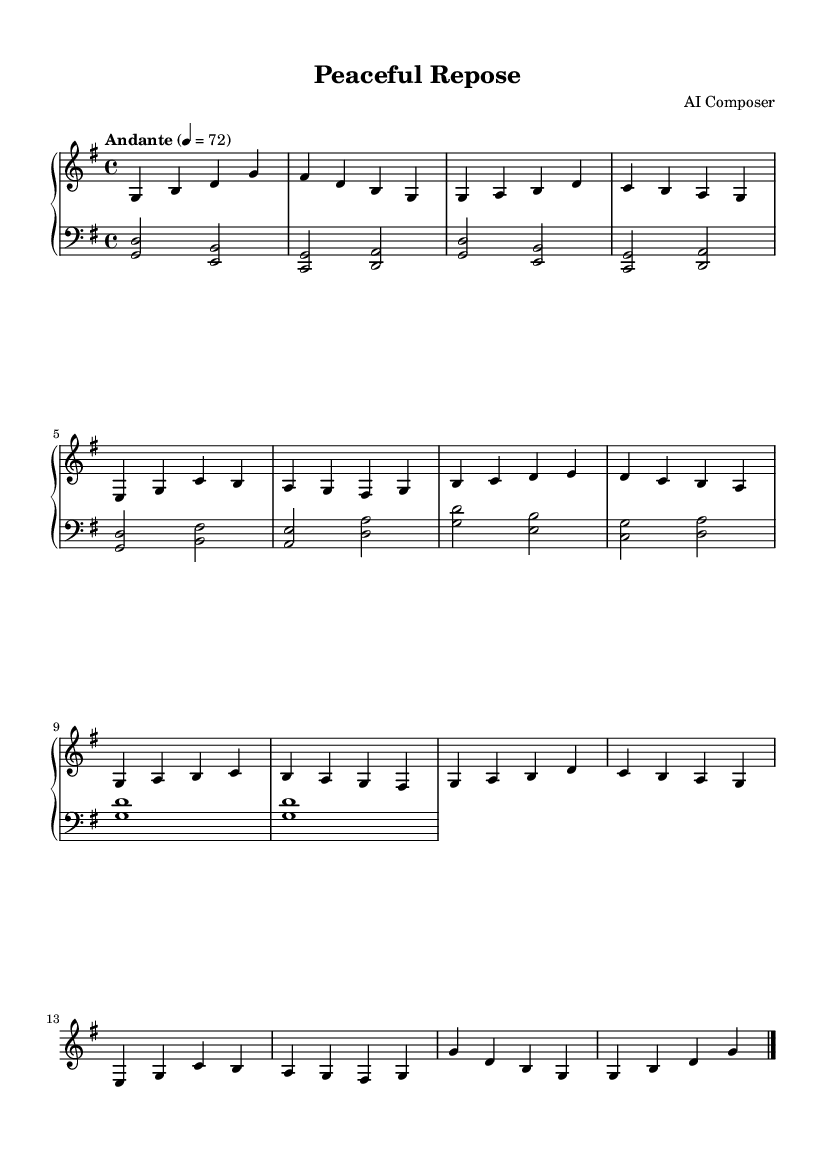What is the key signature of this music? The key signature shows one sharp, which indicates that the piece is in G major.
Answer: G major What is the time signature of this music? The time signature is indicated at the beginning of the sheet music, showing a 4 over 4, meaning there are four beats per measure.
Answer: 4/4 What is the tempo marking for this piece? The tempo marking is indicated just above the staff as "Andante," with a metronome marking of 72 beats per minute, suggesting a moderately slow pace.
Answer: Andante 4 = 72 How many main sections does the piece have? By analyzing the structure of the music, we see sections labeled A and B, and A is repeated, leading to a total of three main sections: A, B, and A prime (A').
Answer: Three What is the last note in the piece? The last note is shown in the ending section, where it follows a G note and is indicated as a whole note at the end of the score.
Answer: G What is the overall mood of this piece as suggested by its title and structure? The title "Peaceful Repose" suggests a calm and soothing atmosphere, which is further supported by the gentle tempo and flowing melodic lines throughout the piece.
Answer: Calm How many measures are in the A section? The A section consists of a total of 8 measures as repeated throughout the music, indicating a clear and balanced structure within that section.
Answer: 8 